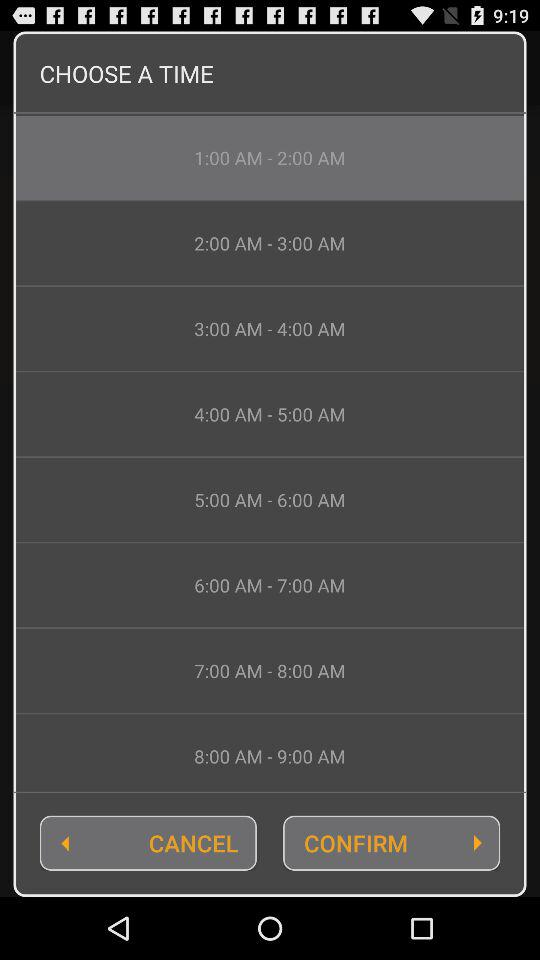What is the selected time range? The selected time range is 1:00 AM - 2:00 AM. 